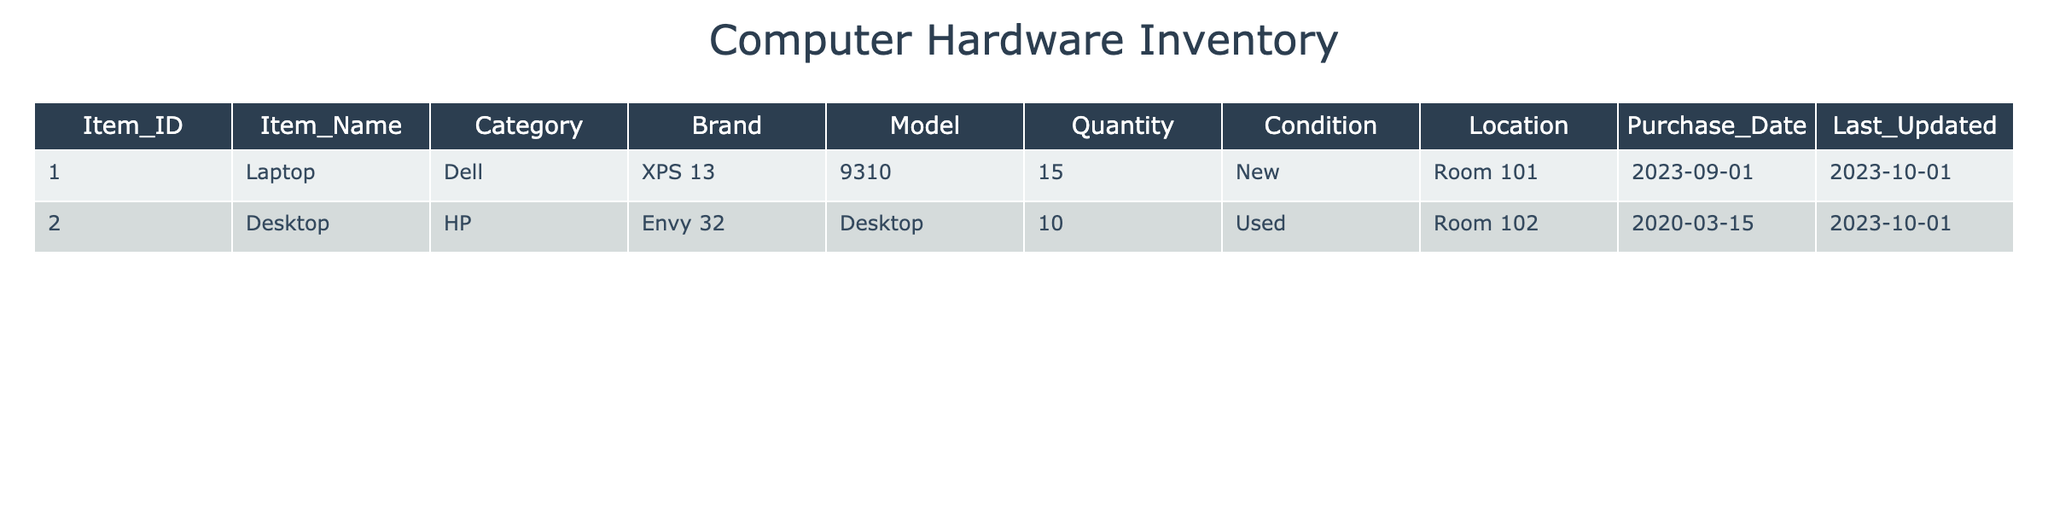What is the total quantity of laptops available? There is one row for laptops in the table. The quantity of laptops listed is 15. Therefore, the total quantity of laptops is simply the quantity in that row.
Answer: 15 Which brand has more items listed in the inventory? The table includes Dell (15 laptops) and HP (10 desktops). To determine which has more, we compare the quantities: Dell has 15 and HP has 10. Since 15 is greater than 10, Dell has more items listed.
Answer: Dell Are there any items that are marked as new? In the table, we see that the laptop (Dell XPS 13) is marked as new, while the desktop (HP Envy 32) is used. Therefore, there is at least one item categorized as new.
Answer: Yes What is the ratio of new items to used items in the inventory? In the inventory, there is 1 new item (Dell laptop) and 1 used item (HP desktop). To find the ratio of new to used items, we use the quantities: 1 new item to 1 used item, which can be expressed as 1:1.
Answer: 1:1 How many total items are in the inventory? The total items are found by adding the quantities in the table: 15 laptops + 10 desktops = 25 total items. Thus, the total count is derived from summing these two quantities.
Answer: 25 What is the average quantity of items per category? There are two categories in the inventory: laptops and desktops. We have 15 laptops and 10 desktops. To find the average, we sum the quantities (15 + 10 = 25) and then divide by the number of categories (2). Therefore, the average quantity is 25/2 = 12.5.
Answer: 12.5 Is the last updated date for all items the same? The table shows that the last updated date for the laptop is 2023-10-01 and for the desktop is also 2023-10-01. Since both dates are identical, we conclude that they have the same last updated date.
Answer: Yes Which item has the most recent purchase date? The table indicates that the Dell laptop has a purchase date of 2023-09-01, while the HP desktop has a date of 2020-03-15. Since 2023-09-01 is more recent than 2020-03-15, the recent purchase date belongs to the Dell laptop.
Answer: Dell XPS 13 What is the difference in quantity between new and used items? There is 1 new item (15 laptops) and 1 used item (10 desktops). The quantity difference is calculated by subtracting the number of used items from the number of new items: 15 - 10 = 5. Therefore, the difference in quantity between new and used items is 5.
Answer: 5 